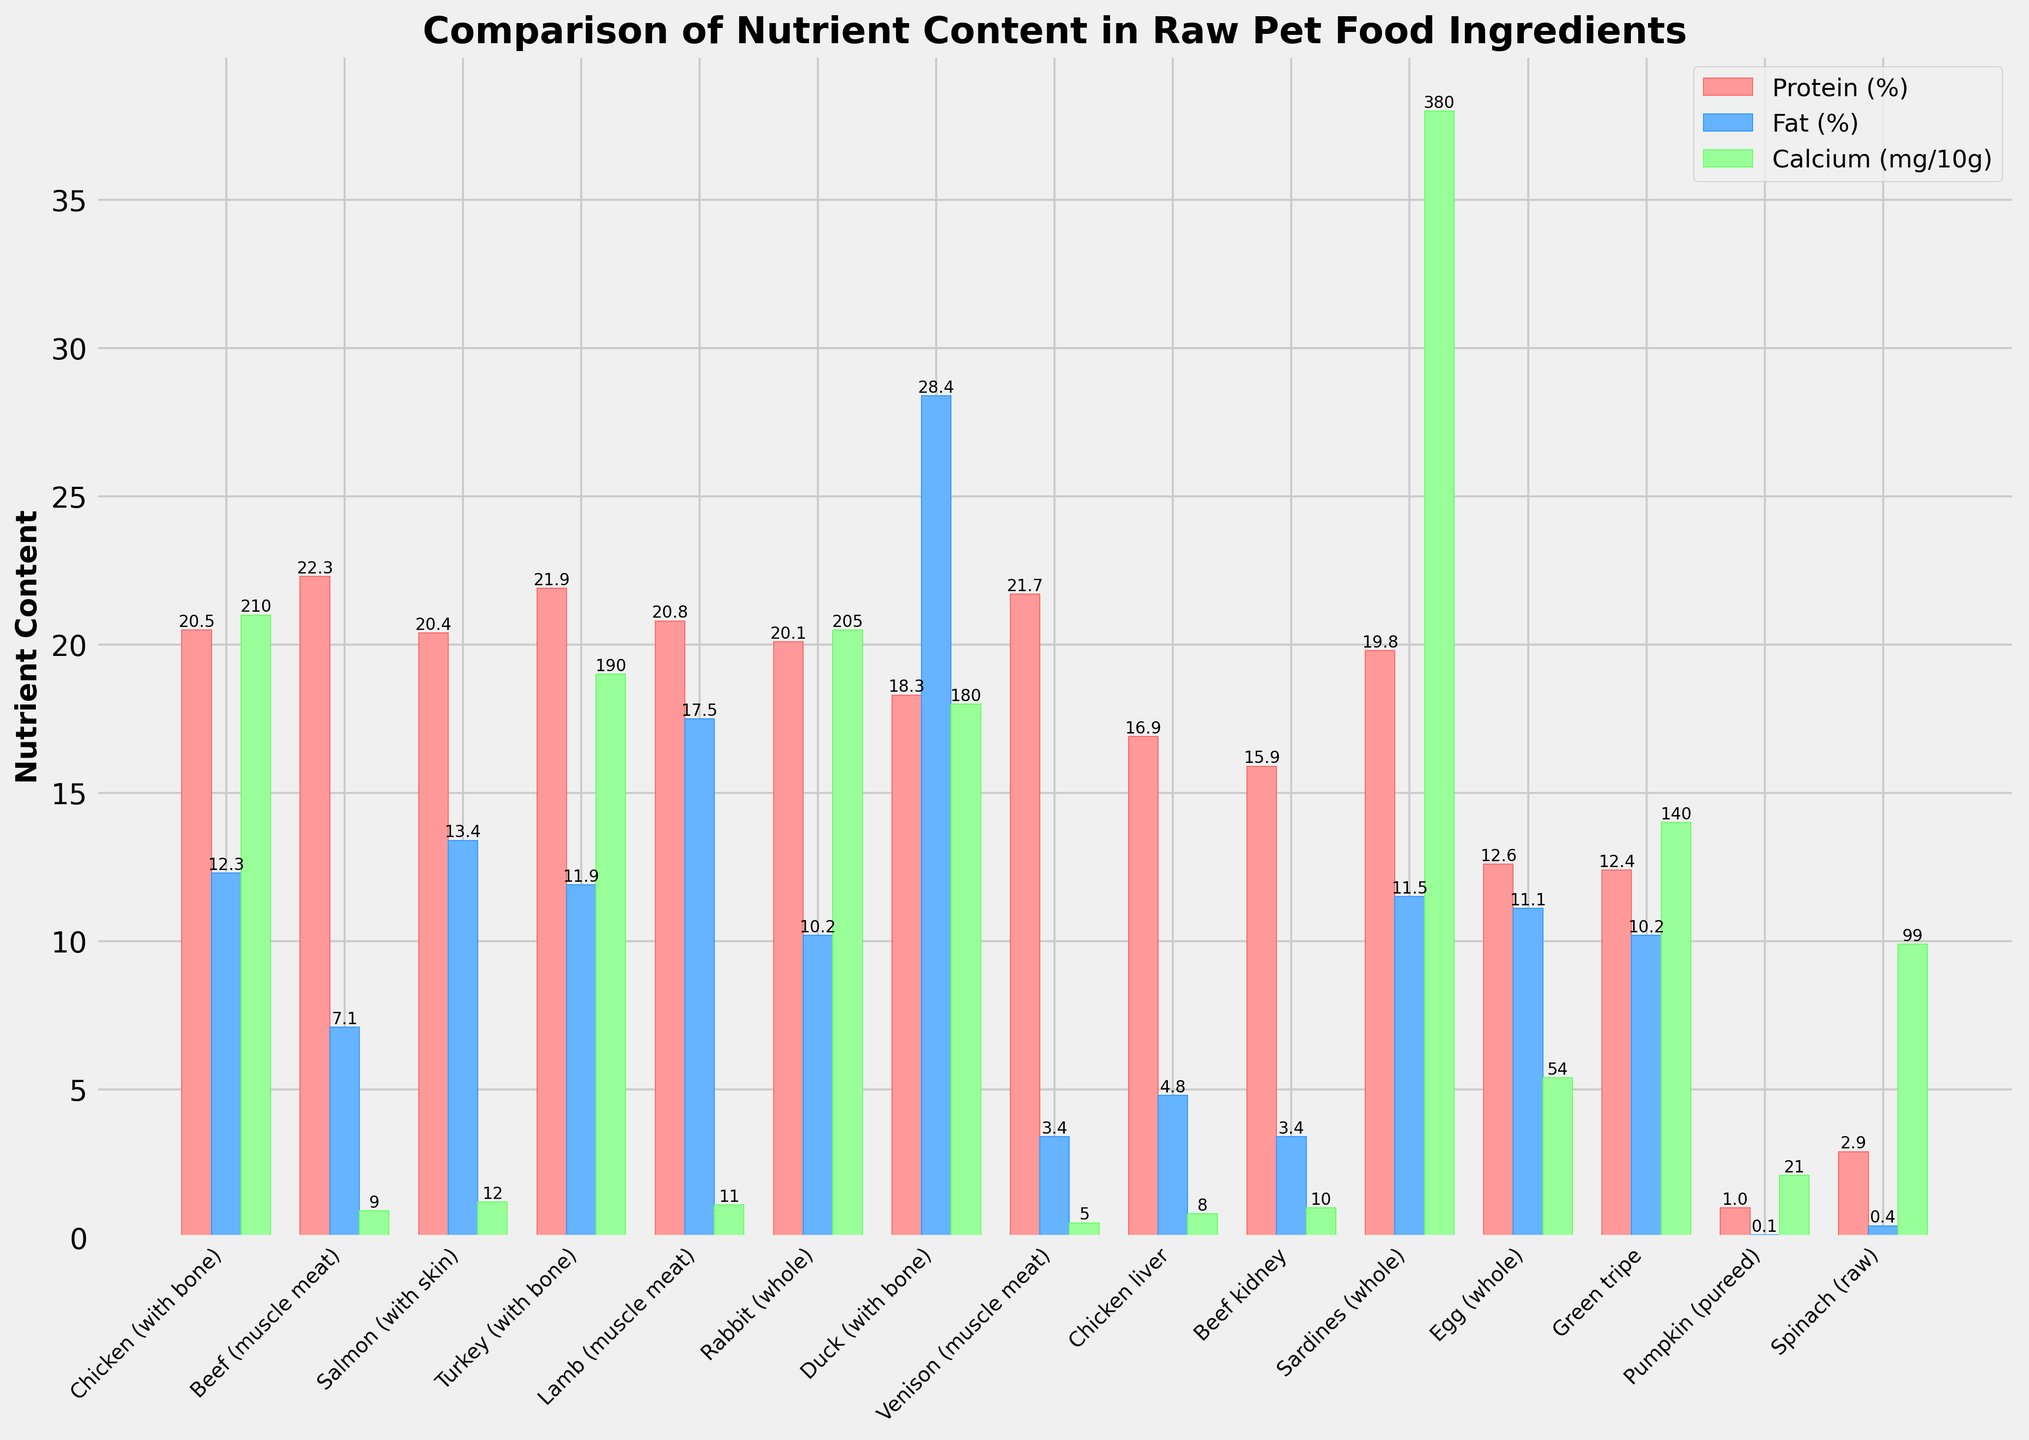Which ingredient has the highest protein content? To find the ingredient with the highest protein content, look at the red bars representing protein (%). The tallest red bar indicates the ingredient with the highest protein percentage. This is "Beef (muscle meat)" with a protein content of 22.3%.
Answer: Beef (muscle meat) Compare the fat content between Chicken (with bone) and Duck (with bone). To compare the fat content, look at the blue bars for these two ingredients. The bar for Duck (with bone) is significantly higher than that for Chicken (with bone), indicating that Duck has much more fat content.
Answer: Duck (with bone) > Chicken (with bone) Rank the following in terms of their calcium content: Sardines (whole), Beef kidney, and Spinach (raw). Examine the green bars for these ingredients. Sardines (whole) has the highest bar, followed by Spinach (raw), and Beef kidney has the smallest bar of the three.
Answer: Sardines > Spinach > Beef kidney What's the average protein content of Chicken liver, Beef kidney, and Pumpkin? Sum the protein values of these ingredients (16.9 for Chicken liver, 15.9 for Beef kidney, and 1.0 for Pumpkin) and divide by 3. The sum is 33.8, and the average is 33.8 / 3 = 11.27.
Answer: 11.27 What is the difference in calcium content between Green tripe and Egg (whole)? Look at the green bars for both ingredients to find their calcium content. Green tripe has 140 mg/100g, while Egg (whole) has 54 mg/100g. The difference is 140 - 54 = 86 mg/100g.
Answer: 86 mg/100g Which ingredient has the lowest fat content? Look for the smallest blue bar representing fat content. The shortest blue bar is for Venison (muscle meat) with 3.4%.
Answer: Venison (muscle meat) How does the protein content of Rabbit (whole) compare to that of Salmon (with skin)? Compare the red bars of these two ingredients. Both bars are very close, but Salmon (with skin) has a slightly higher protein content (20.4%) compared to Rabbit (whole) which has 20.1%.
Answer: Salmon (with skin) > Rabbit (whole) Based on the chart, which ingredient would you expect to be richest in calcium per 100g intake? Look for the tallest green bar since it represents the calcium content. Sardines (whole) has the highest green bar, indicating the highest calcium content at 380 mg/100g.
Answer: Sardines (whole) What is the total fat content for Beef (muscle meat), Turkey (with bone), and Egg (whole)? Sum up their fat content values (7.1 for Beef, 11.9 for Turkey, and 11.1 for Egg). The total is 7.1 + 11.9 + 11.1 = 30.1%.
Answer: 30.1% In terms of protein content, which ingredient is superior - Lamb (muscle meat) or Venison (muscle meat)? Compare the red bars for Lamb (muscle meat) and Venison (muscle meat). Venison (muscle meat) has a slightly taller red bar indicating it has higher protein content (21.7%) compared to Lamb (muscle meat) which has 20.8%.
Answer: Venison (muscle meat) 